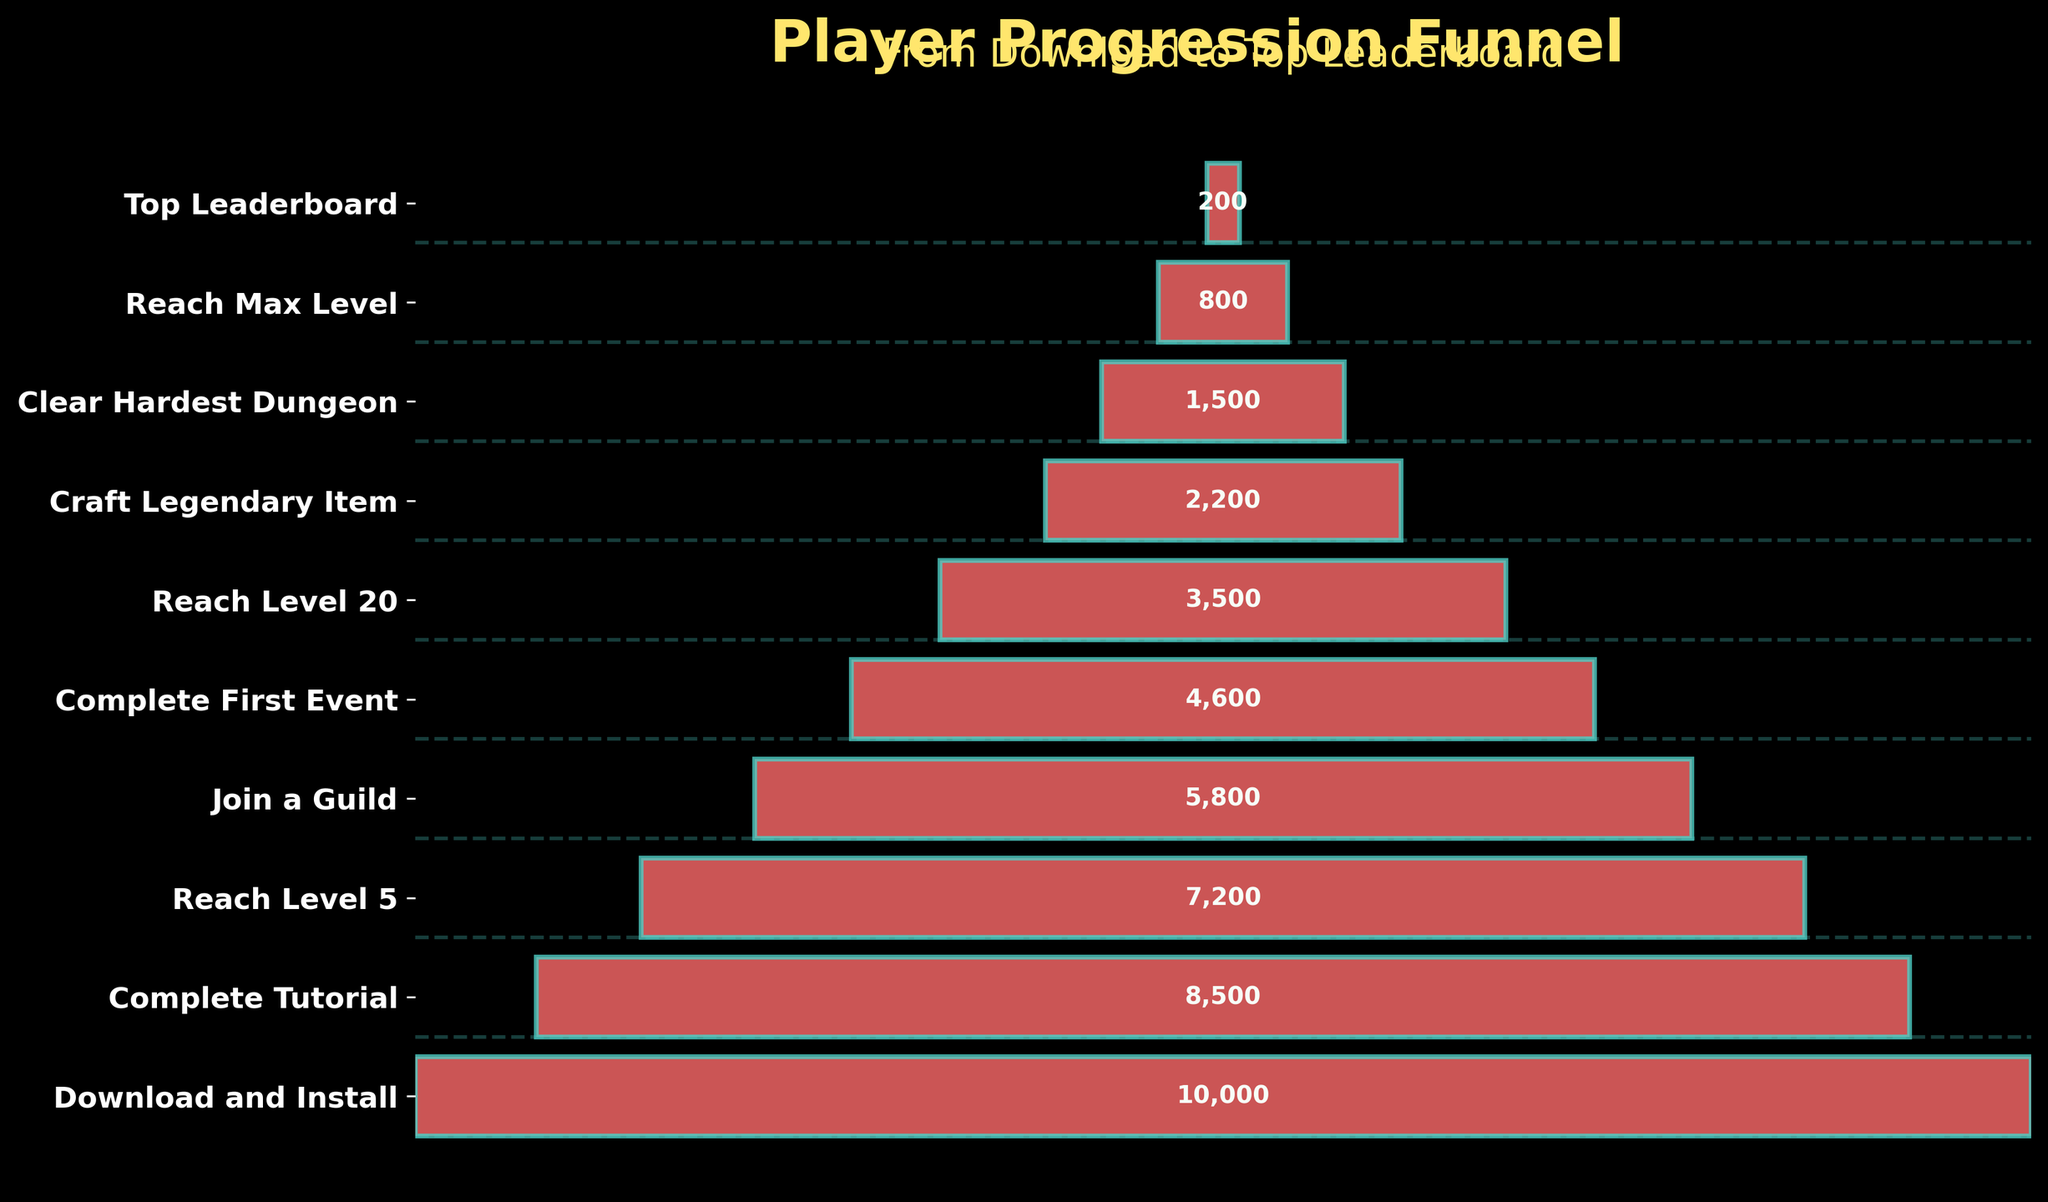Which stage has the highest number of players? The funnel chart begins with the 'Download and Install' stage where it indicates the highest count of players before any progression drop-off. By looking at the top section of the funnel, we see 10,000 players listed there.
Answer: Download and Install Which stage has the lowest number of players? To identify the stage with the fewest players, observe the bottom section of the funnel chart. The lowest player count is shown in the 'Top Leaderboard' stage with only 200 players.
Answer: Top Leaderboard How many players reached the Max Level stage? By examining the funnel chart, we locate the 'Reach Max Level' stage and note that it indicates 800 players progressed to this stage.
Answer: 800 What's the difference in the number of players between the 'Join a Guild' stage and the 'Complete First Event' stage? Find and compare the player counts in the stages 'Join a Guild' (5800 players) and 'Complete First Event' (4600 players) from the chart. The difference is 5800 - 4600 = 1200 players.
Answer: 1200 Which stage shows a significant drop in players compared to the previous stage? Identify stages with substantial reductions by comparing consecutive stages. Noticeable drop is from 'Craft Legendary Item' (2200 players) to 'Clear Hardest Dungeon' (1500 players). The drop is 2200 - 1500 = 700 players.
Answer: Clear Hardest Dungeon How many players in total reached at least the 'Reach Level 20' stage? Calculate the sum of players at 'Reach Level 20' (3500), 'Craft Legendary Item' (2200), 'Clear Hardest Dungeon' (1500), 'Reach Max Level' (800), and 'Top Leaderboard' (200) stages. Sum = 3500 + 2200 + 1500 + 800 + 200 = 8200 players.
Answer: 8200 What is the ratio of players that joined a guild compared to the total downloads and installations? Calculate the ratio of players who joined a guild (5800) to the initial downloads (10,000). The ratio is 5800 / 10000 = 0.58.
Answer: 0.58 Identify two stages where the difference in player count is the smallest. Examine the differences in player counts between each consecutive stage. The smallest difference is between 'Complete Tutorial' (8500) and 'Reach Level 5' (7200), and 'Complete First Event' (4600) and 'Reach Level 20' (3500). Both differences are 8500 - 7200 = 1300, and 4600 - 3500 = 1100 respectively. However, since 1100 is less, the stages are 'Complete First Event' and 'Reach Level 20'.
Answer: Complete First Event and Reach Level 20 